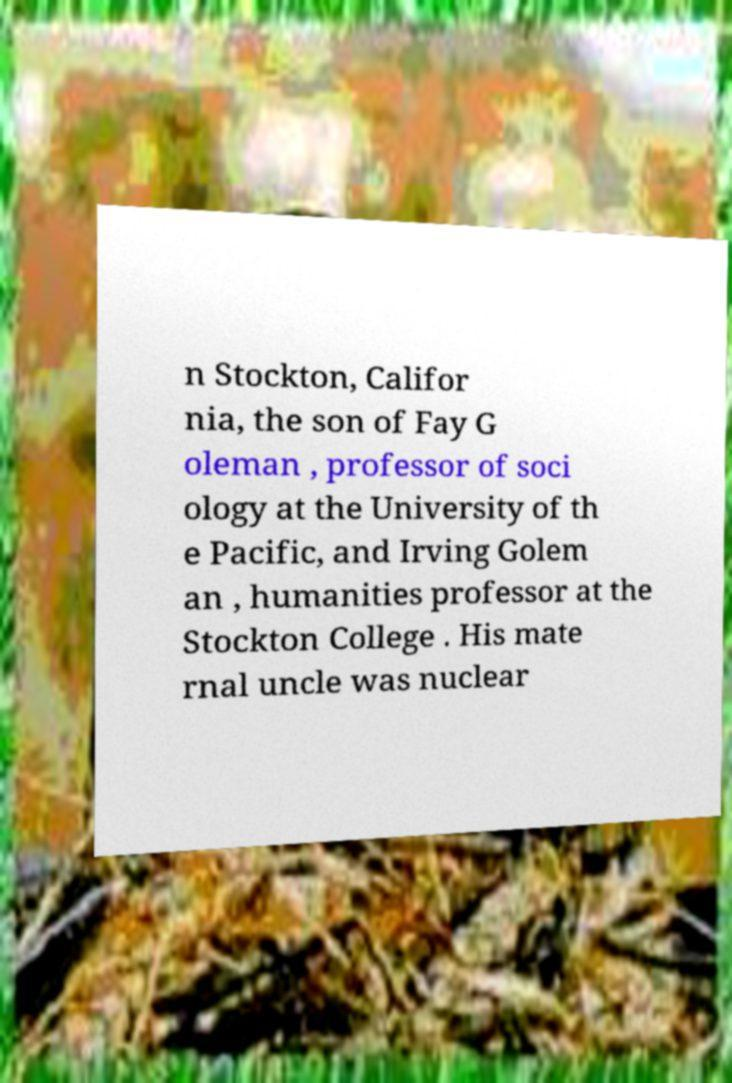Can you accurately transcribe the text from the provided image for me? n Stockton, Califor nia, the son of Fay G oleman , professor of soci ology at the University of th e Pacific, and Irving Golem an , humanities professor at the Stockton College . His mate rnal uncle was nuclear 